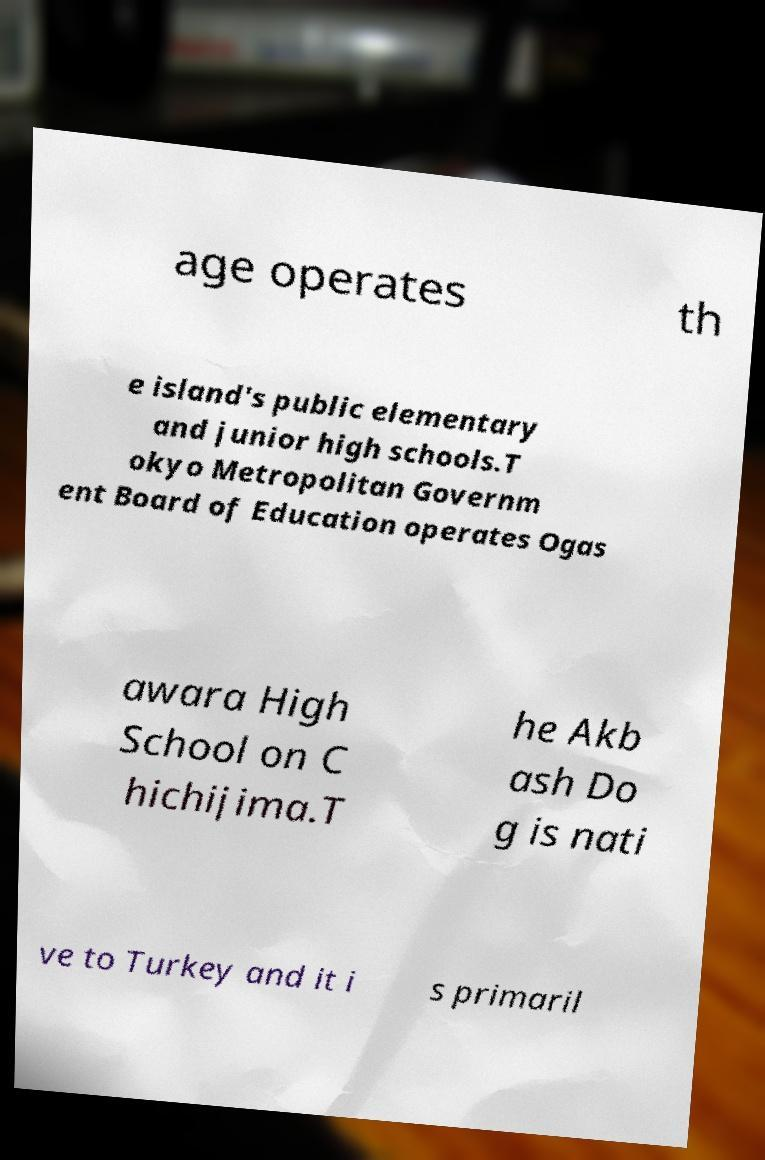Could you extract and type out the text from this image? age operates th e island's public elementary and junior high schools.T okyo Metropolitan Governm ent Board of Education operates Ogas awara High School on C hichijima.T he Akb ash Do g is nati ve to Turkey and it i s primaril 